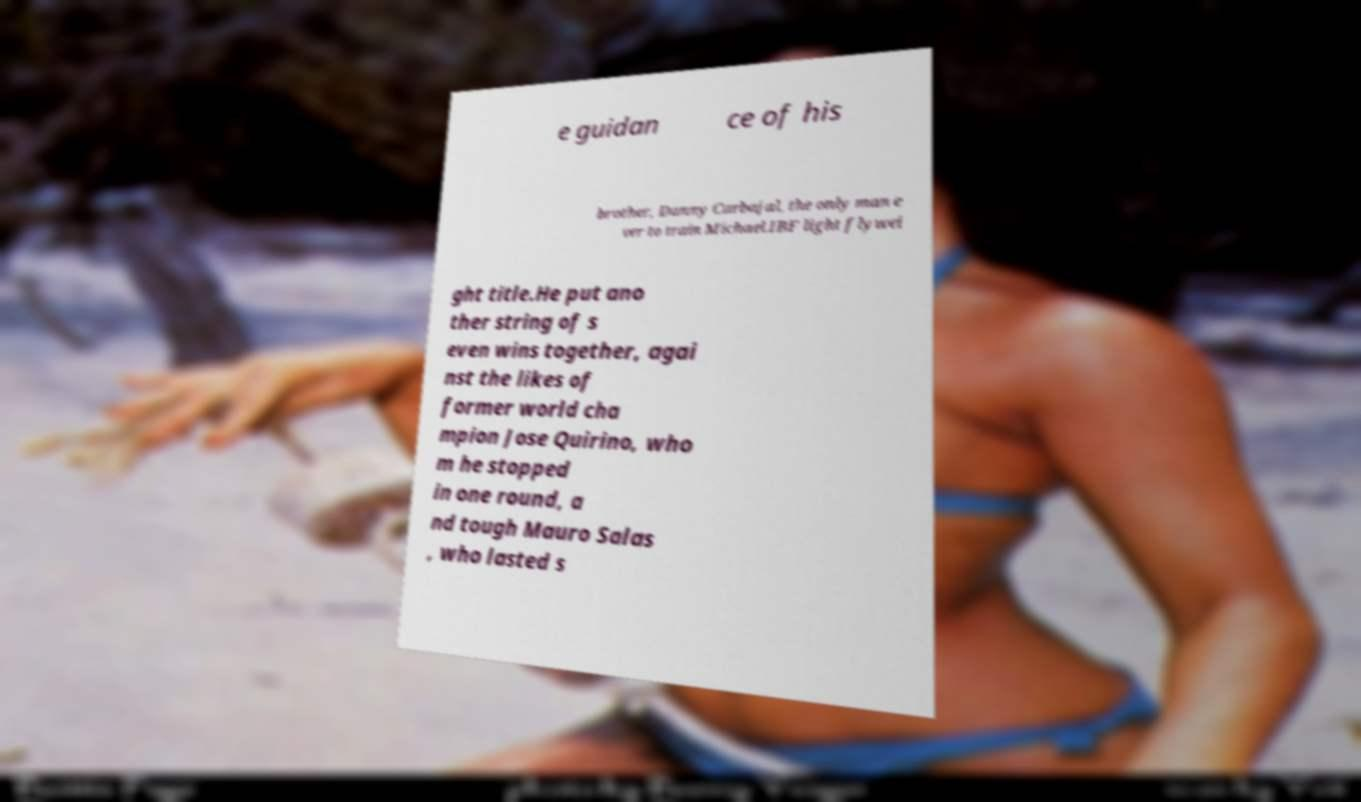Could you extract and type out the text from this image? e guidan ce of his brother, Danny Carbajal, the only man e ver to train Michael.IBF light flywei ght title.He put ano ther string of s even wins together, agai nst the likes of former world cha mpion Jose Quirino, who m he stopped in one round, a nd tough Mauro Salas , who lasted s 